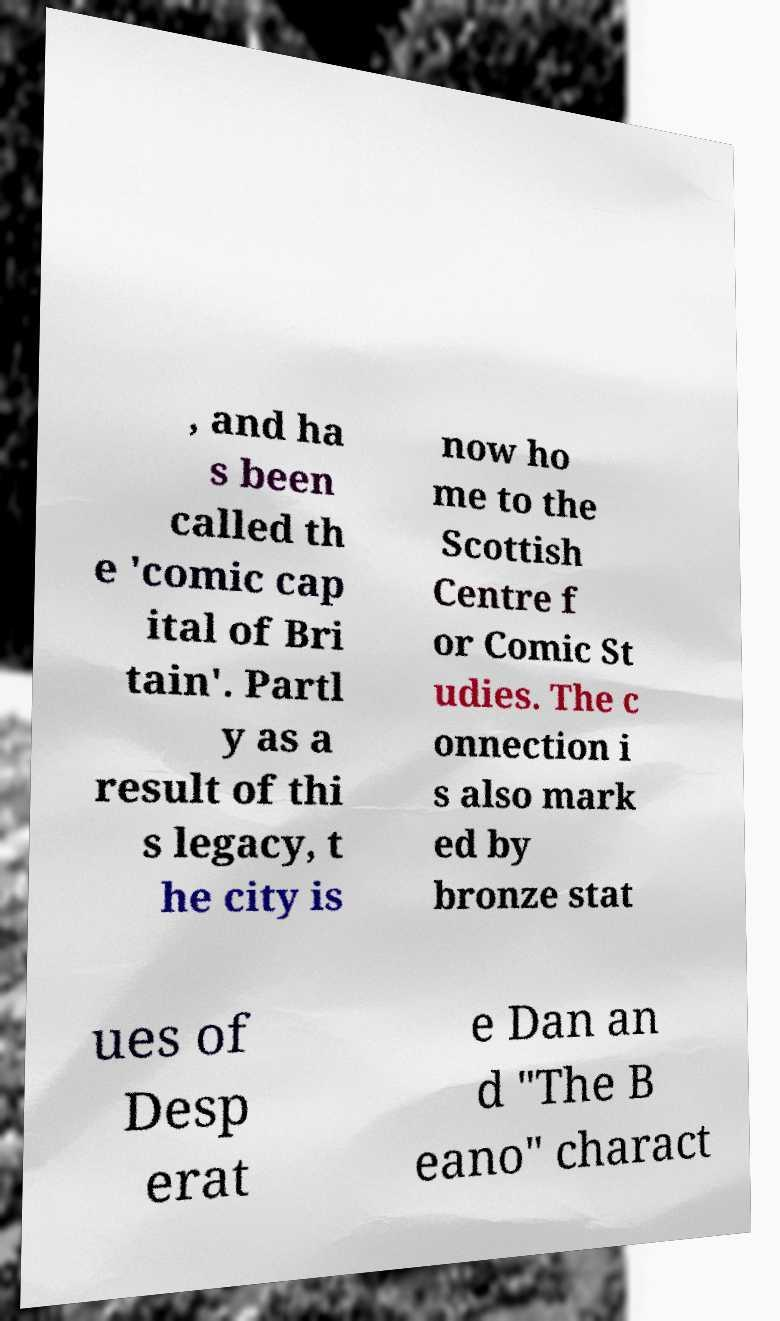What messages or text are displayed in this image? I need them in a readable, typed format. , and ha s been called th e 'comic cap ital of Bri tain'. Partl y as a result of thi s legacy, t he city is now ho me to the Scottish Centre f or Comic St udies. The c onnection i s also mark ed by bronze stat ues of Desp erat e Dan an d "The B eano" charact 